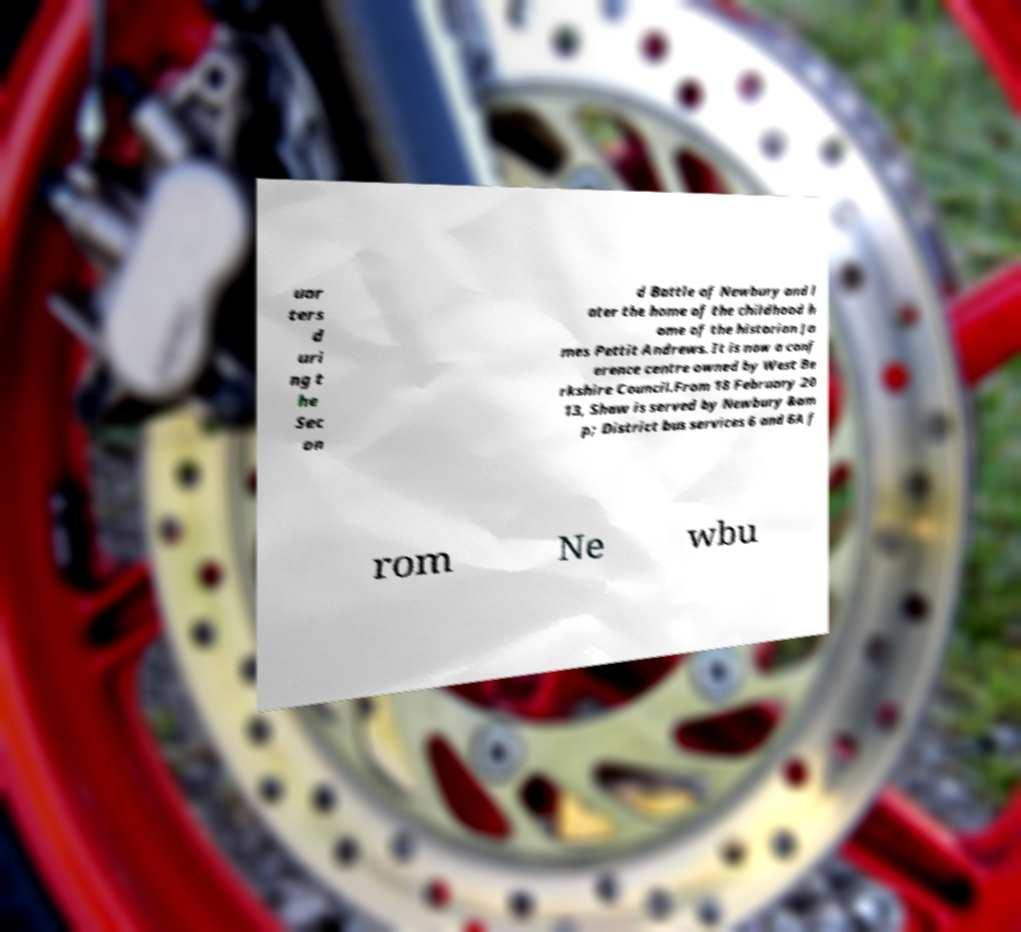Please read and relay the text visible in this image. What does it say? uar ters d uri ng t he Sec on d Battle of Newbury and l ater the home of the childhood h ome of the historian Ja mes Pettit Andrews. It is now a conf erence centre owned by West Be rkshire Council.From 18 February 20 13, Shaw is served by Newbury &am p; District bus services 6 and 6A f rom Ne wbu 